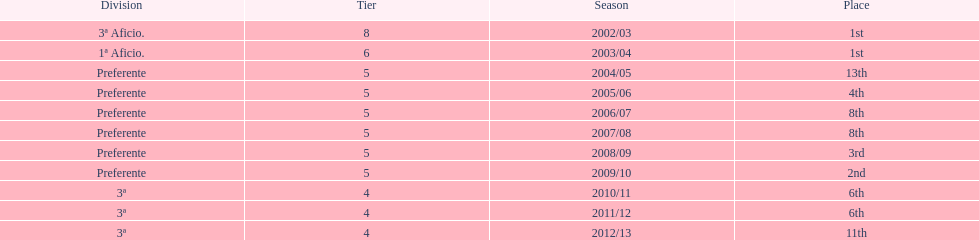How long has internacional de madrid cf been playing in the 3ª division? 3. 